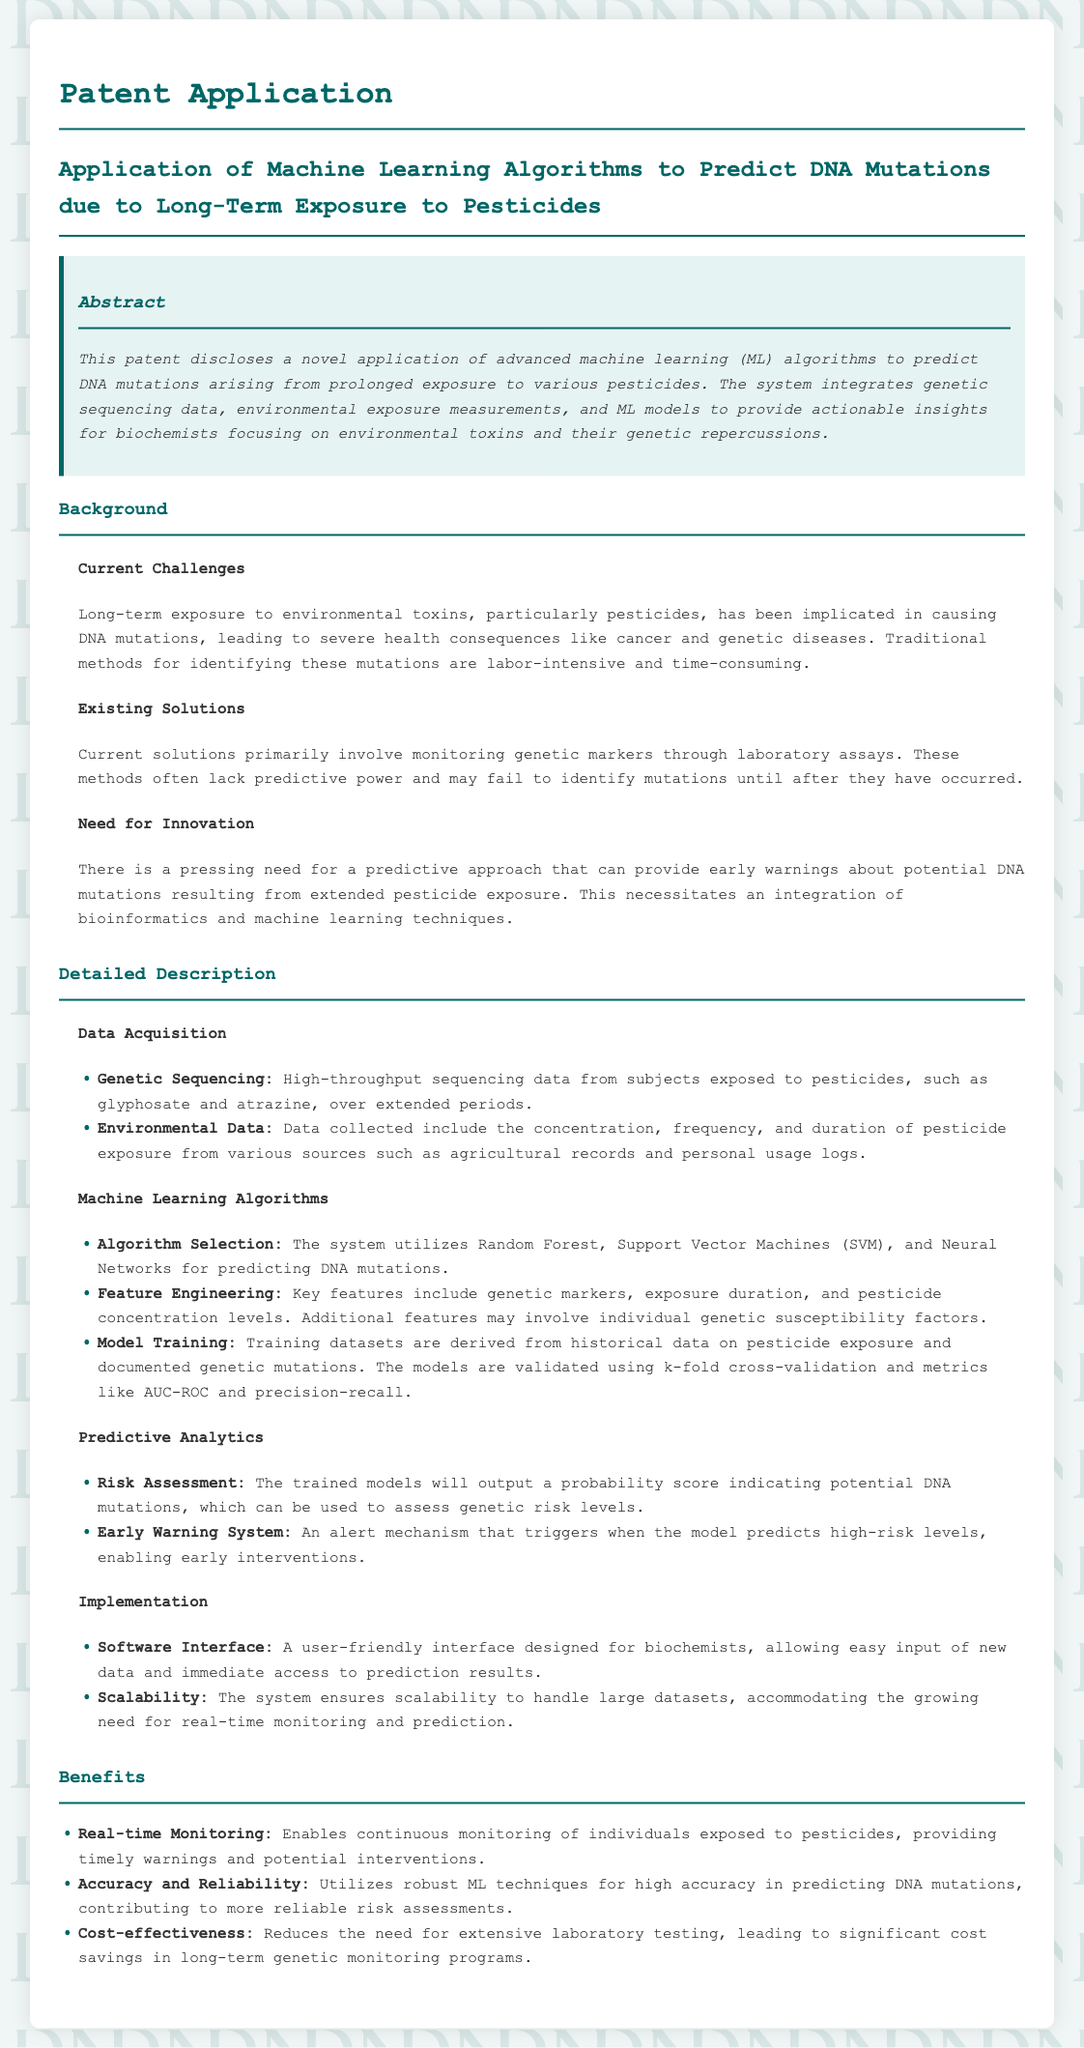what is the focus of the patent application? The patent application focuses on the application of advanced machine learning algorithms to predict DNA mutations due to long-term exposure to pesticides.
Answer: predicting DNA mutations due to long-term exposure to pesticides what are the machine learning algorithms mentioned? The patent mentions Random Forest, Support Vector Machines (SVM), and Neural Networks as the machine learning algorithms utilized.
Answer: Random Forest, Support Vector Machines (SVM), Neural Networks what type of data is used for model training? The model training uses historical data on pesticide exposure and documented genetic mutations as training datasets.
Answer: historical data on pesticide exposure and documented genetic mutations what is the purpose of the early warning system? The purpose is to trigger an alert when high-risk levels are predicted, enabling early interventions.
Answer: enable early interventions how does the system ensure scalability? The system ensures scalability to handle large datasets, accommodating the growing need for real-time monitoring and prediction.
Answer: handle large datasets what is one of the benefits of real-time monitoring? One of the benefits is providing timely warnings and potential interventions for individuals exposed to pesticides.
Answer: timely warnings and potential interventions what aspect of existing solutions is highlighted as a problem? It highlights that current solutions often lack predictive power and may fail to identify mutations until after they have occurred.
Answer: lack predictive power what is the primary goal of integrating bioinformatics and machine learning techniques? The primary goal is to provide a predictive approach that can give early warnings about potential DNA mutations from pesticide exposure.
Answer: provide a predictive approach for early warnings 